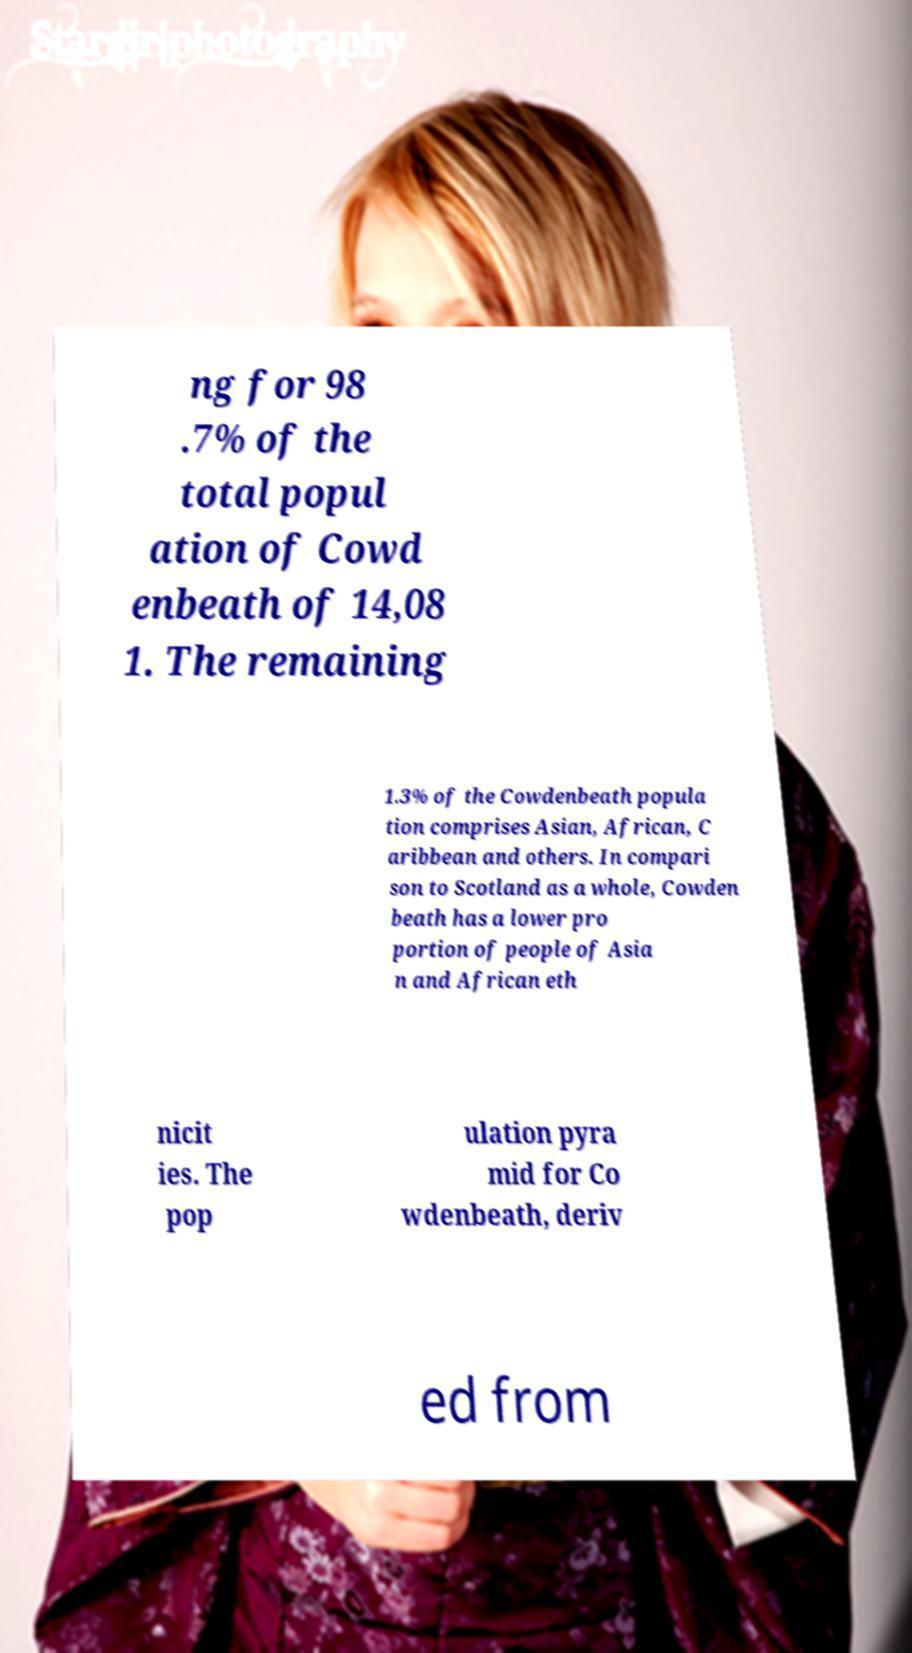There's text embedded in this image that I need extracted. Can you transcribe it verbatim? ng for 98 .7% of the total popul ation of Cowd enbeath of 14,08 1. The remaining 1.3% of the Cowdenbeath popula tion comprises Asian, African, C aribbean and others. In compari son to Scotland as a whole, Cowden beath has a lower pro portion of people of Asia n and African eth nicit ies. The pop ulation pyra mid for Co wdenbeath, deriv ed from 